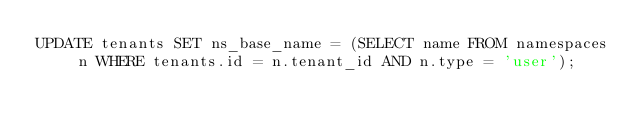Convert code to text. <code><loc_0><loc_0><loc_500><loc_500><_SQL_>UPDATE tenants SET ns_base_name = (SELECT name FROM namespaces n WHERE tenants.id = n.tenant_id AND n.type = 'user');
</code> 